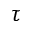Convert formula to latex. <formula><loc_0><loc_0><loc_500><loc_500>\tau</formula> 